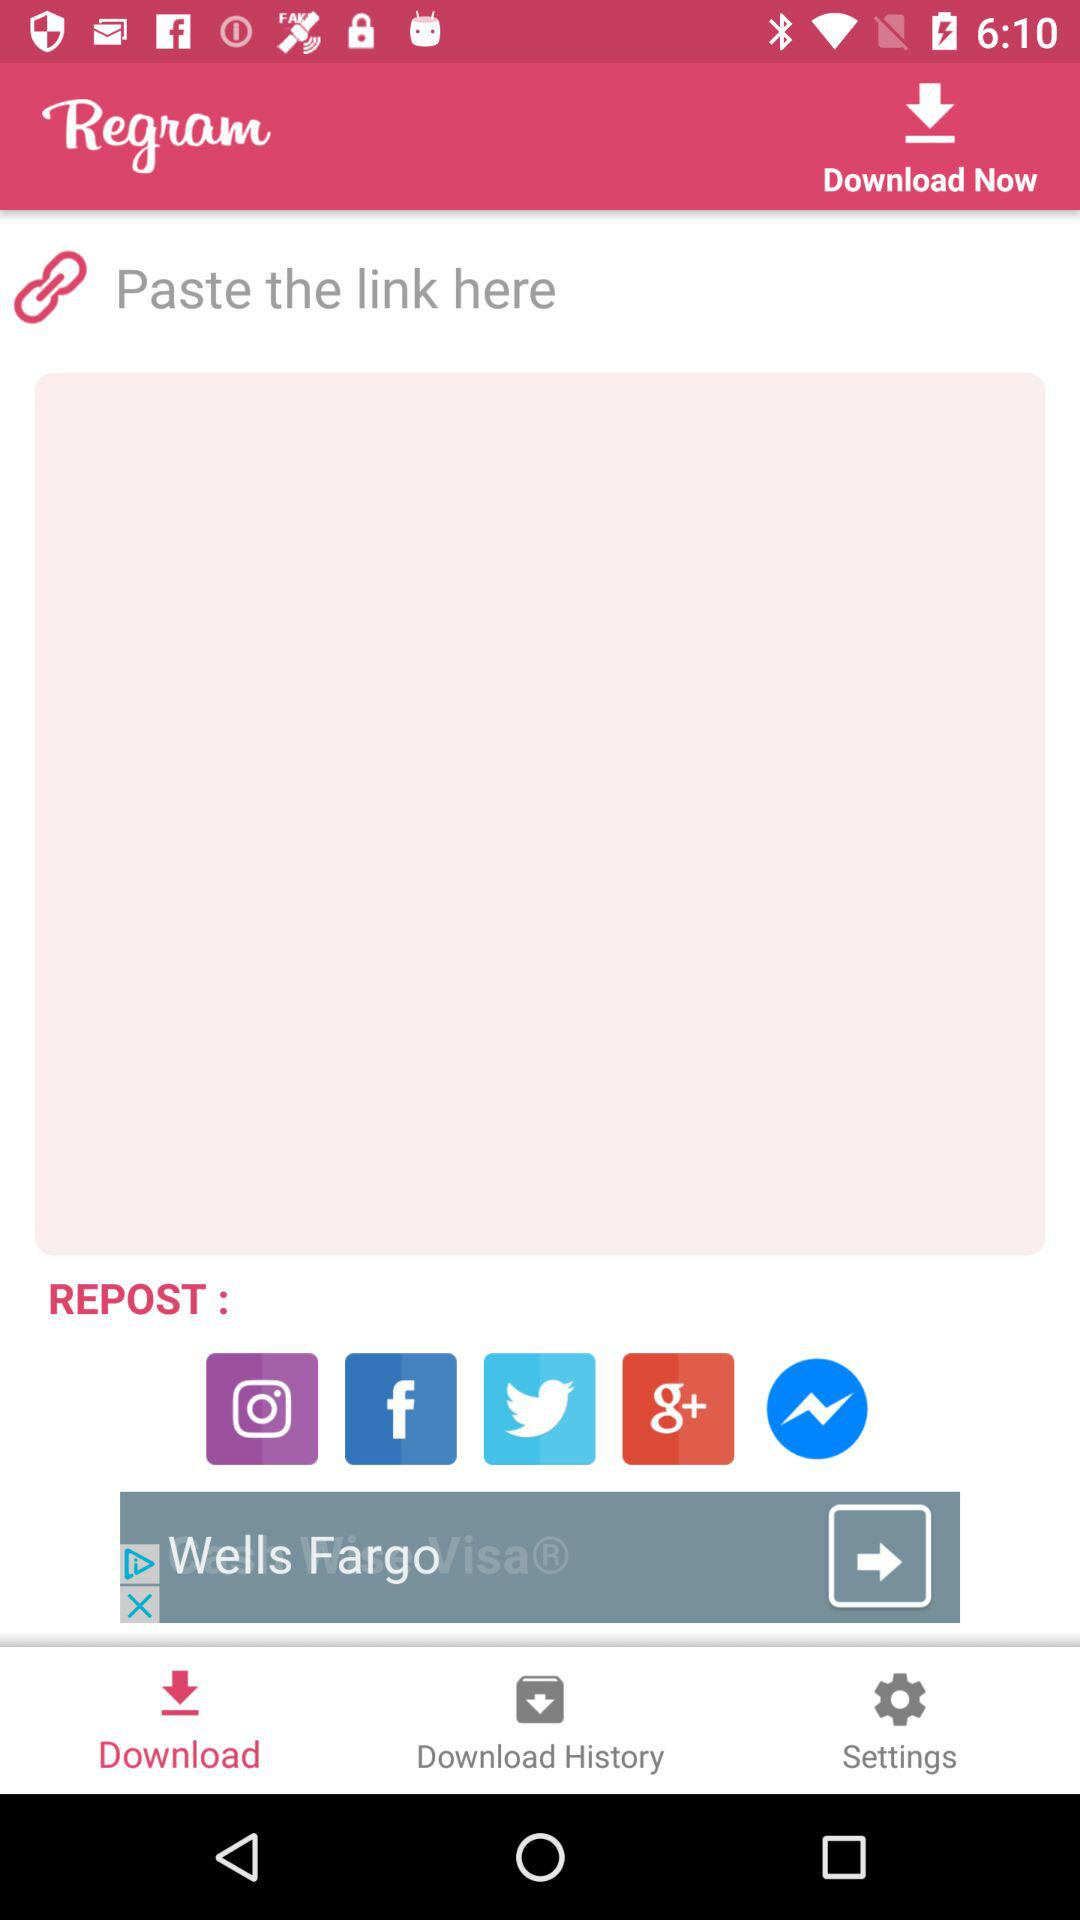What is the app name? The app name is "Regram". 